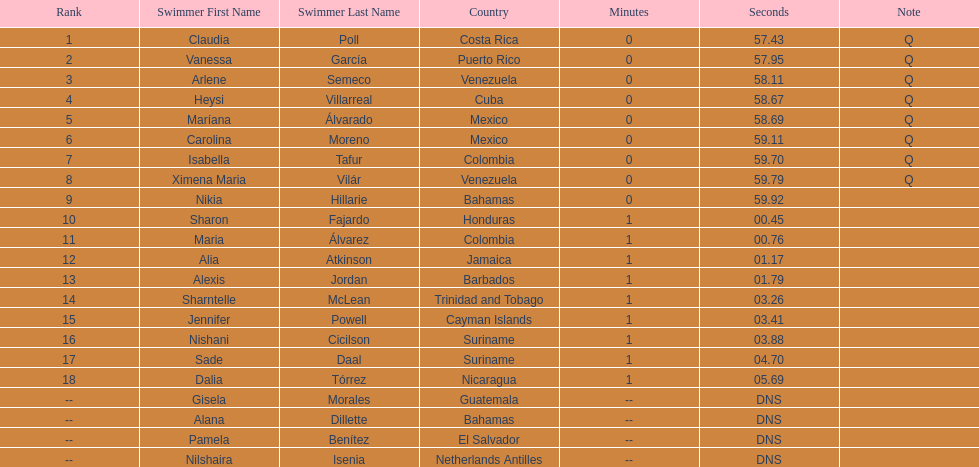How many competitors did not start the preliminaries? 4. 